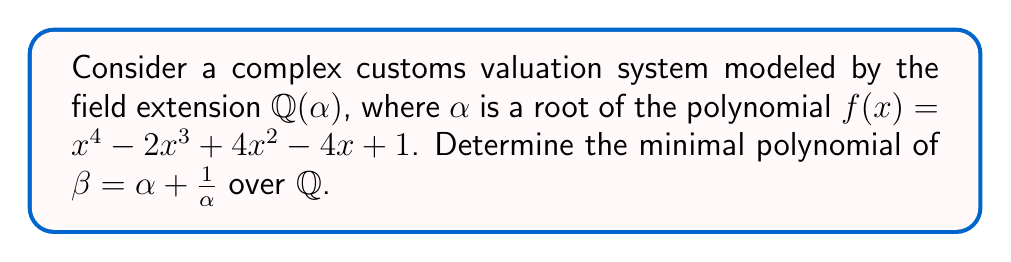Provide a solution to this math problem. 1) First, we need to express $\beta$ in terms of $\alpha$:
   $\beta = \alpha + \frac{1}{\alpha}$

2) Multiply both sides by $\alpha$:
   $\alpha\beta = \alpha^2 + 1$

3) Rearrange to get:
   $\alpha^2 = \alpha\beta - 1$

4) Now, substitute this into the original polynomial $f(x)$:
   $(\alpha\beta - 1)^2 - 2\alpha^3 + 4(\alpha\beta - 1) - 4\alpha + 1 = 0$

5) Expand:
   $\alpha^2\beta^2 - 2\alpha\beta + 1 - 2\alpha^3 + 4\alpha\beta - 4 - 4\alpha + 1 = 0$

6) Substitute $\alpha^2 = \alpha\beta - 1$ again:
   $(\alpha\beta - 1)\beta^2 - 2\alpha\beta + 1 - 2\alpha(\alpha\beta - 1) + 4\alpha\beta - 4 - 4\alpha + 1 = 0$

7) Expand:
   $\alpha\beta^3 - \beta^2 - 2\alpha\beta + 1 - 2\alpha^2\beta + 2\alpha + 4\alpha\beta - 4 - 4\alpha + 1 = 0$

8) Substitute $\alpha^2 = \alpha\beta - 1$ one more time:
   $\alpha\beta^3 - \beta^2 - 2\alpha\beta + 1 - 2(\alpha\beta - 1)\beta + 2\alpha + 4\alpha\beta - 4 - 4\alpha + 1 = 0$

9) Expand and collect terms:
   $\alpha\beta^3 - \beta^2 - 2\alpha\beta + 1 - 2\alpha\beta^2 + 2\beta + 2\alpha + 4\alpha\beta - 4 - 4\alpha + 1 = 0$
   $\alpha(\beta^3 - 2\beta^2 - 2\beta + 4\beta - 2) + (-\beta^2 + 2\beta - 2) = 0$

10) For this to be true for all $\alpha$, both coefficients must be zero:
    $\beta^3 - 2\beta^2 + 2\beta - 2 = 0$ and $-\beta^2 + 2\beta - 2 = 0$

11) The second equation is of lower degree, so it must be the minimal polynomial of $\beta$.

Therefore, the minimal polynomial of $\beta$ over $\mathbb{Q}$ is $x^2 - 2x + 2$.
Answer: $x^2 - 2x + 2$ 